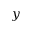Convert formula to latex. <formula><loc_0><loc_0><loc_500><loc_500>y</formula> 